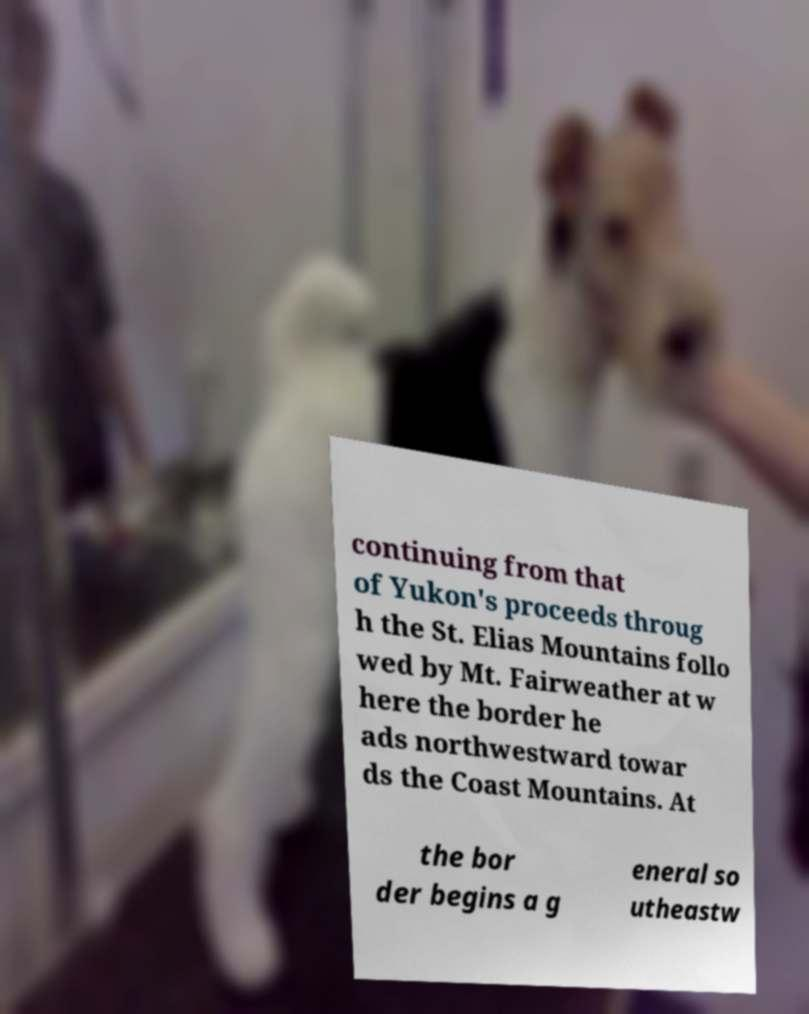For documentation purposes, I need the text within this image transcribed. Could you provide that? continuing from that of Yukon's proceeds throug h the St. Elias Mountains follo wed by Mt. Fairweather at w here the border he ads northwestward towar ds the Coast Mountains. At the bor der begins a g eneral so utheastw 